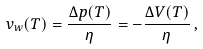Convert formula to latex. <formula><loc_0><loc_0><loc_500><loc_500>v _ { w } ( T ) = \frac { \Delta p ( T ) } { \eta } = - \frac { \Delta V ( T ) } { \eta } \, ,</formula> 